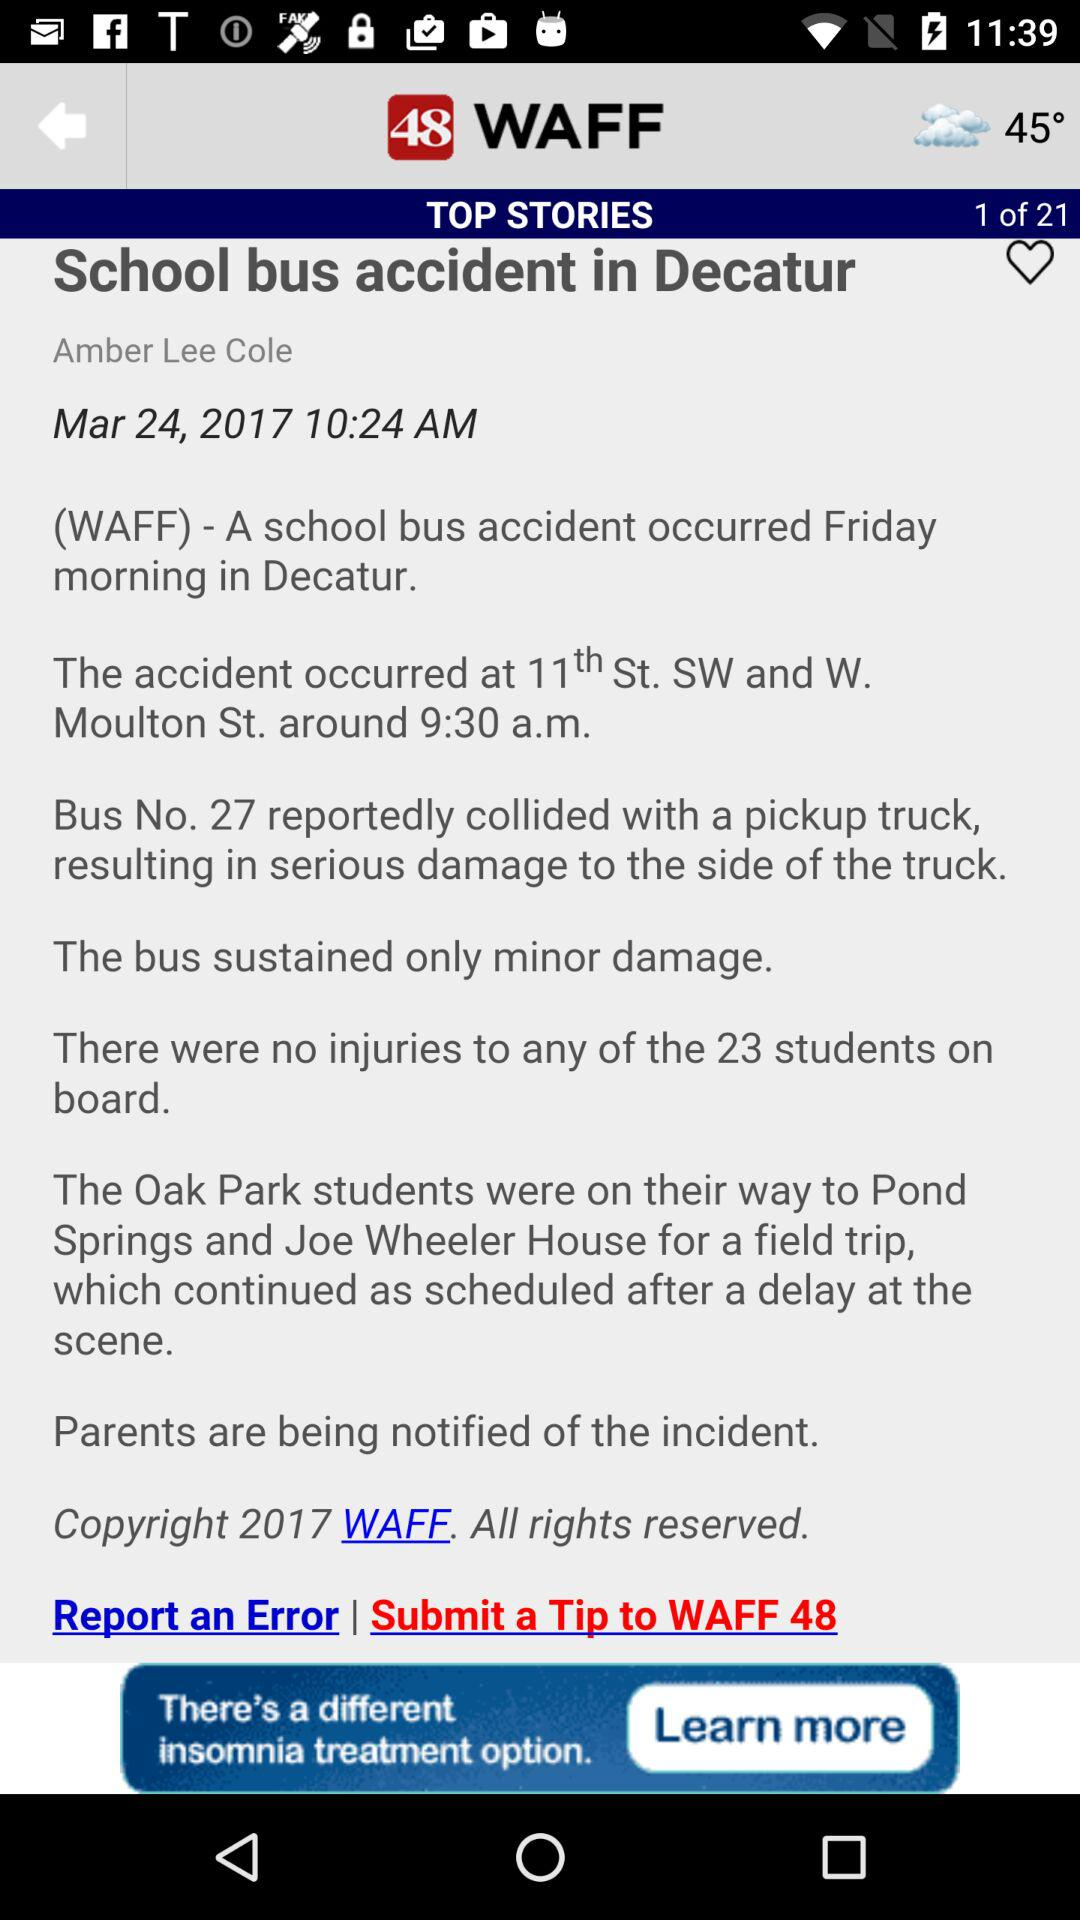What is the total number of stories? The total number of stories is 21. 